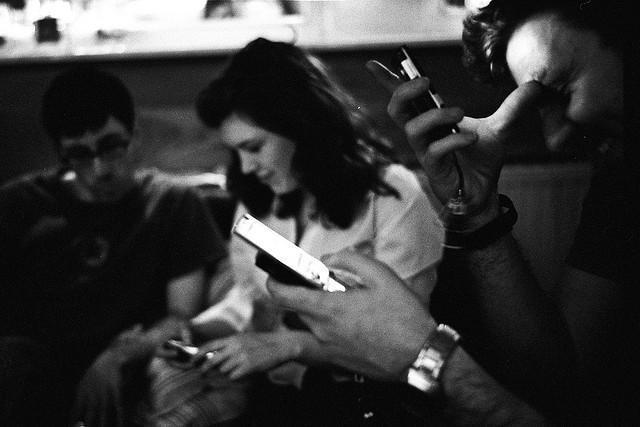How many people are there?
Give a very brief answer. 3. How many sandwiches do you see?
Give a very brief answer. 0. 